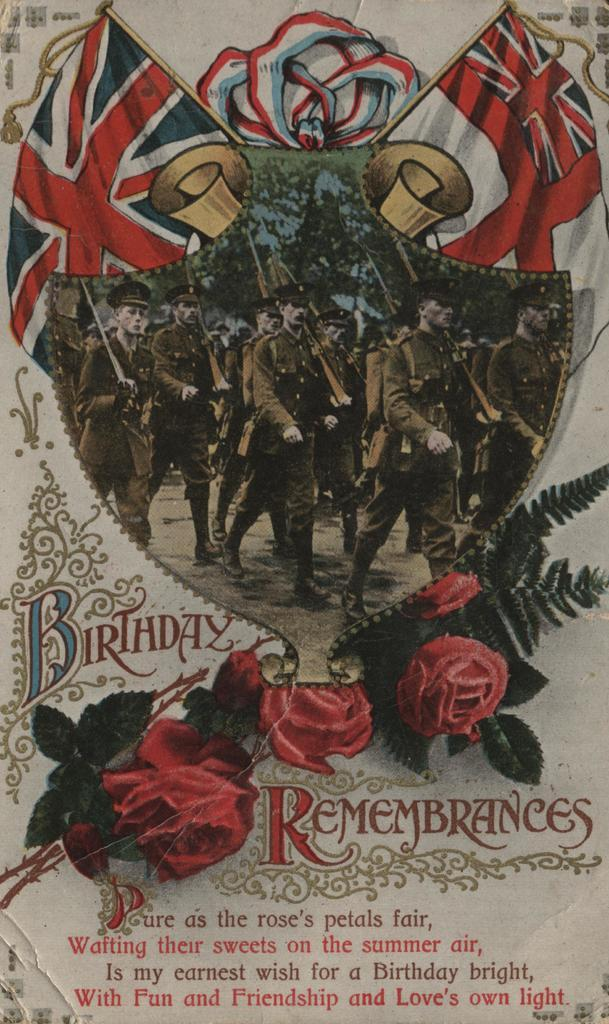<image>
Write a terse but informative summary of the picture. An antique style Birthday Rememberances card with a poem on it. 